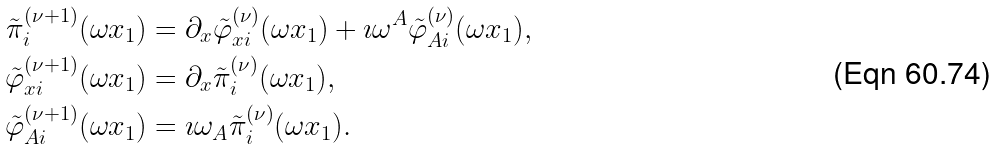Convert formula to latex. <formula><loc_0><loc_0><loc_500><loc_500>\tilde { \pi } ^ { ( \nu + 1 ) } _ { i } ( \omega x _ { 1 } ) & = \partial _ { x } \tilde { \varphi } ^ { ( \nu ) } _ { x i } ( \omega x _ { 1 } ) + \imath \omega ^ { A } \tilde { \varphi } ^ { ( \nu ) } _ { A i } ( \omega x _ { 1 } ) , \\ \tilde { \varphi } ^ { ( \nu + 1 ) } _ { x i } ( \omega x _ { 1 } ) & = \partial _ { x } \tilde { \pi } ^ { ( \nu ) } _ { i } ( \omega x _ { 1 } ) , \\ \tilde { \varphi } ^ { ( \nu + 1 ) } _ { A i } ( \omega x _ { 1 } ) & = \imath \omega _ { A } \tilde { \pi } ^ { ( \nu ) } _ { i } ( \omega x _ { 1 } ) .</formula> 